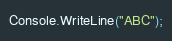<code> <loc_0><loc_0><loc_500><loc_500><_C#_>Console.WriteLine("ABC");</code> 